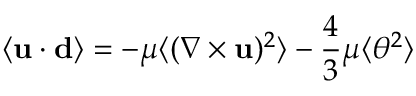Convert formula to latex. <formula><loc_0><loc_0><loc_500><loc_500>\langle { u } \cdot { d } \rangle = - \mu \langle ( \nabla \times { u } ) ^ { 2 } \rangle - { \frac { 4 } { 3 } } \mu \langle \theta ^ { 2 } \rangle</formula> 